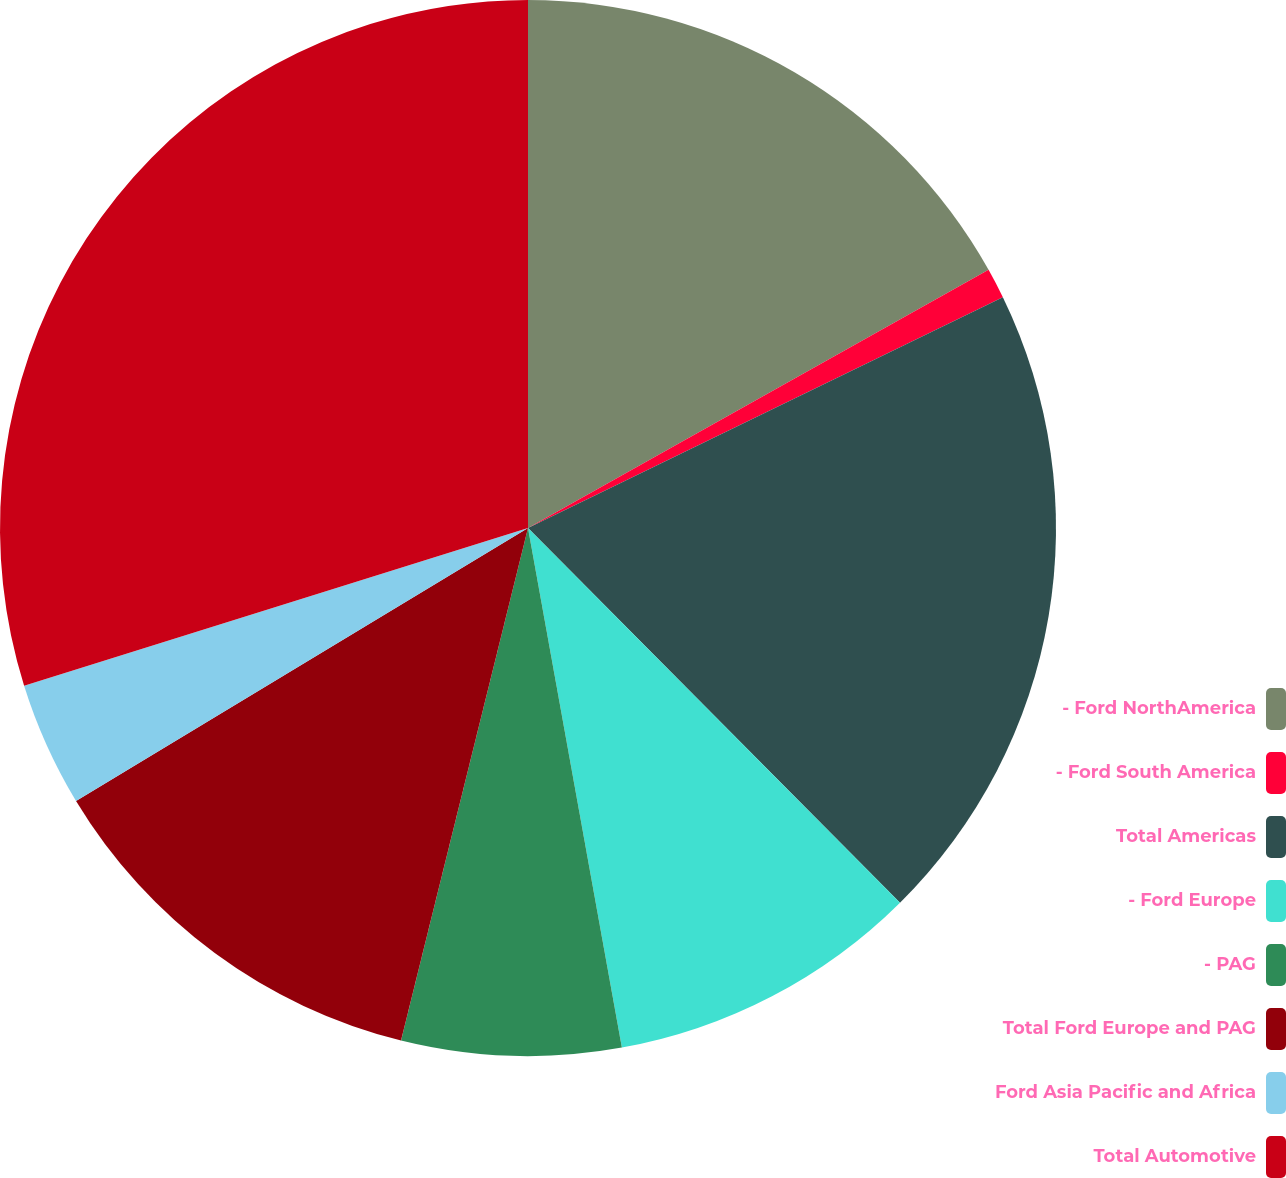Convert chart. <chart><loc_0><loc_0><loc_500><loc_500><pie_chart><fcel>- Ford NorthAmerica<fcel>- Ford South America<fcel>Total Americas<fcel>- Ford Europe<fcel>- PAG<fcel>Total Ford Europe and PAG<fcel>Ford Asia Pacific and Africa<fcel>Total Automotive<nl><fcel>16.87%<fcel>0.93%<fcel>19.76%<fcel>9.6%<fcel>6.71%<fcel>12.49%<fcel>3.82%<fcel>29.83%<nl></chart> 